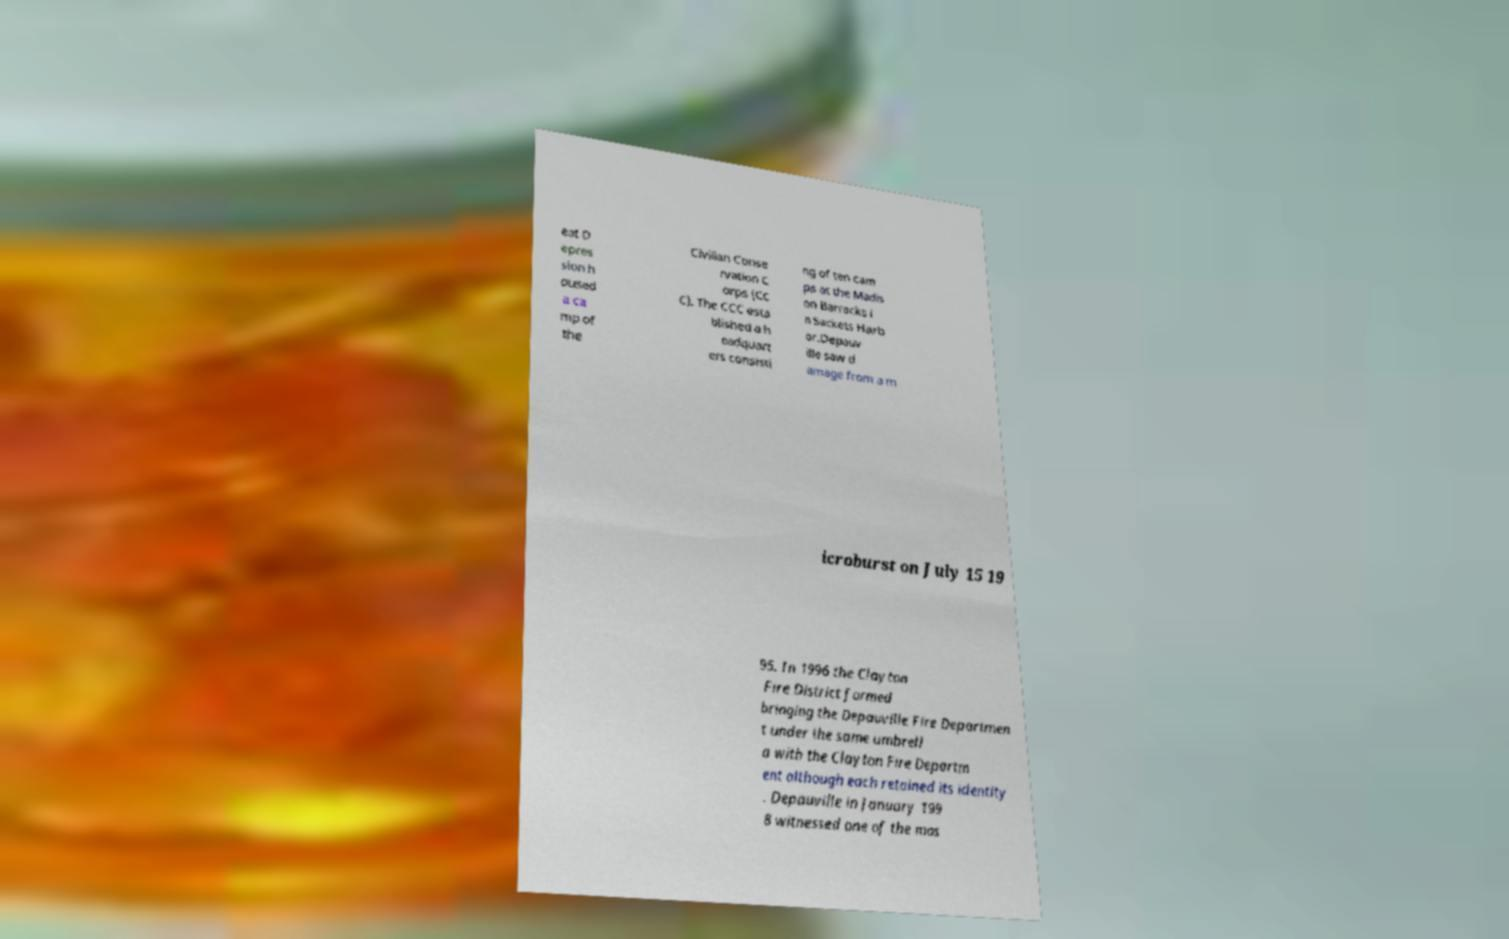Please read and relay the text visible in this image. What does it say? eat D epres sion h oused a ca mp of the Civilian Conse rvation C orps (CC C). The CCC esta blished a h eadquart ers consisti ng of ten cam ps at the Madis on Barracks i n Sackets Harb or.Depauv ille saw d amage from a m icroburst on July 15 19 95. In 1996 the Clayton Fire District formed bringing the Depauville Fire Departmen t under the same umbrell a with the Clayton Fire Departm ent although each retained its identity . Depauville in January 199 8 witnessed one of the mos 